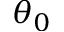Convert formula to latex. <formula><loc_0><loc_0><loc_500><loc_500>\theta _ { 0 }</formula> 